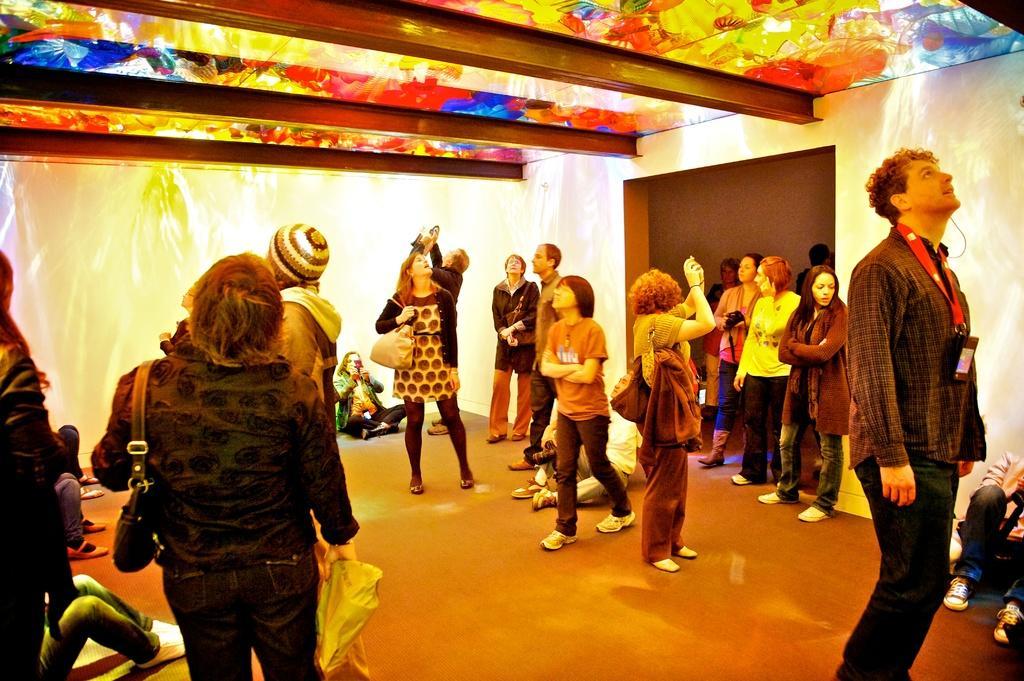In one or two sentences, can you explain what this image depicts? In this image I can see the group of people with different color dresses and few people are wearing the bags. I can see the colorful ceiling in the top. 